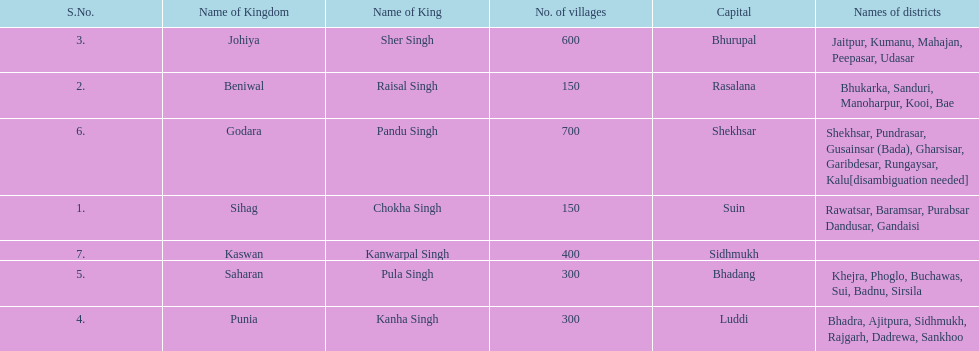Parse the table in full. {'header': ['S.No.', 'Name of Kingdom', 'Name of King', 'No. of villages', 'Capital', 'Names of districts'], 'rows': [['3.', 'Johiya', 'Sher Singh', '600', 'Bhurupal', 'Jaitpur, Kumanu, Mahajan, Peepasar, Udasar'], ['2.', 'Beniwal', 'Raisal Singh', '150', 'Rasalana', 'Bhukarka, Sanduri, Manoharpur, Kooi, Bae'], ['6.', 'Godara', 'Pandu Singh', '700', 'Shekhsar', 'Shekhsar, Pundrasar, Gusainsar (Bada), Gharsisar, Garibdesar, Rungaysar, Kalu[disambiguation needed]'], ['1.', 'Sihag', 'Chokha Singh', '150', 'Suin', 'Rawatsar, Baramsar, Purabsar Dandusar, Gandaisi'], ['7.', 'Kaswan', 'Kanwarpal Singh', '400', 'Sidhmukh', ''], ['5.', 'Saharan', 'Pula Singh', '300', 'Bhadang', 'Khejra, Phoglo, Buchawas, Sui, Badnu, Sirsila'], ['4.', 'Punia', 'Kanha Singh', '300', 'Luddi', 'Bhadra, Ajitpura, Sidhmukh, Rajgarh, Dadrewa, Sankhoo']]} He was the king of the sihag kingdom. Chokha Singh. 